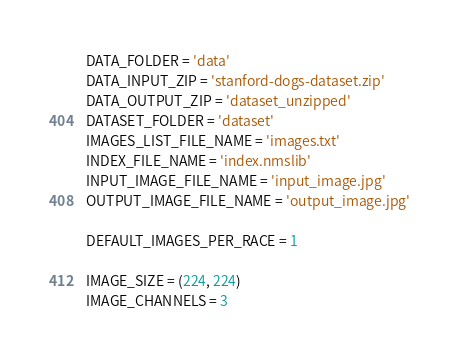<code> <loc_0><loc_0><loc_500><loc_500><_Python_>DATA_FOLDER = 'data'
DATA_INPUT_ZIP = 'stanford-dogs-dataset.zip'
DATA_OUTPUT_ZIP = 'dataset_unzipped'
DATASET_FOLDER = 'dataset'
IMAGES_LIST_FILE_NAME = 'images.txt'
INDEX_FILE_NAME = 'index.nmslib'
INPUT_IMAGE_FILE_NAME = 'input_image.jpg'
OUTPUT_IMAGE_FILE_NAME = 'output_image.jpg'

DEFAULT_IMAGES_PER_RACE = 1

IMAGE_SIZE = (224, 224)
IMAGE_CHANNELS = 3
</code> 